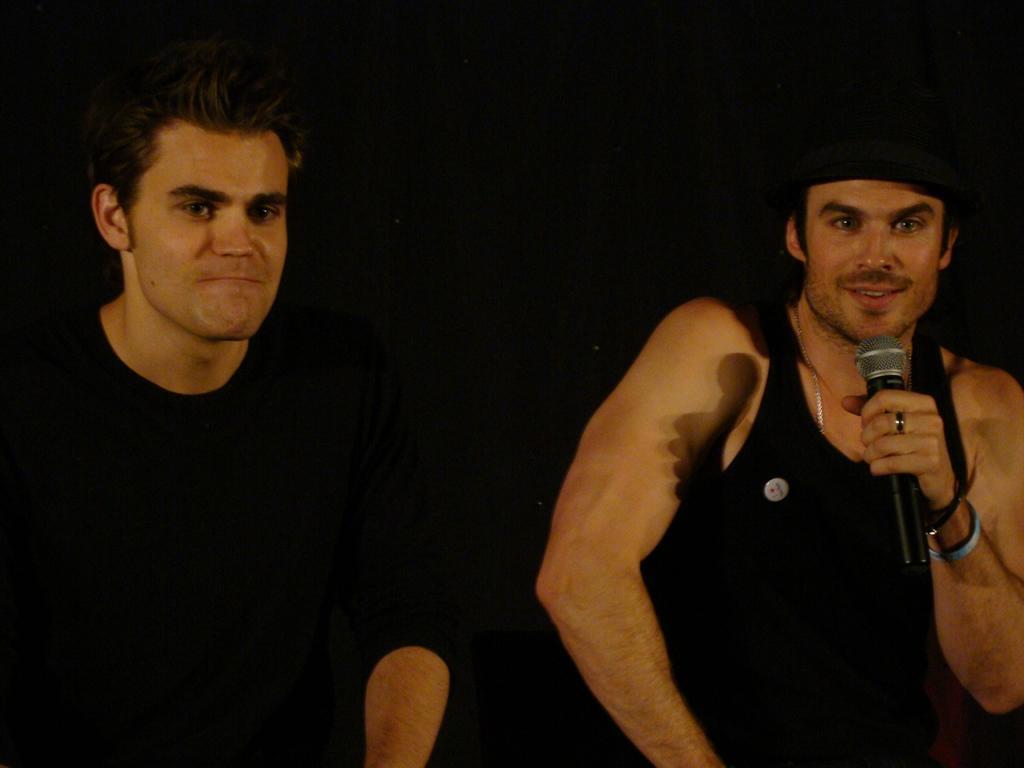Please provide a concise description of this image. In this image, there are two persons wearing clothes. There is a person who is on the right side of the image holding a mic with his hand and wearing a cap on his head. 